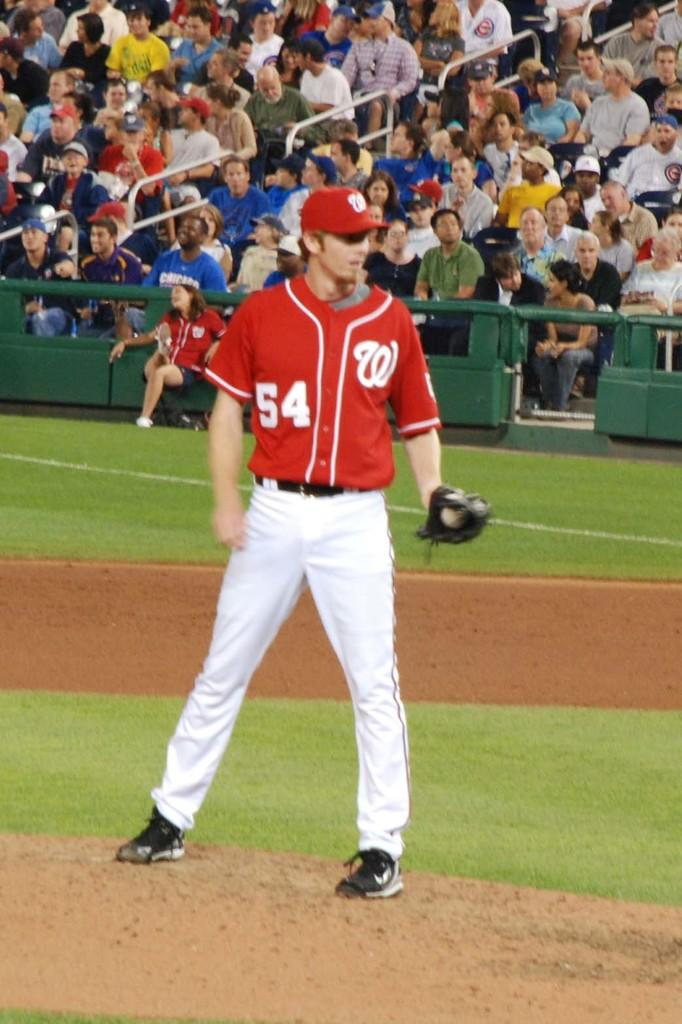<image>
Create a compact narrative representing the image presented. a player that has the letter W on their jersey 